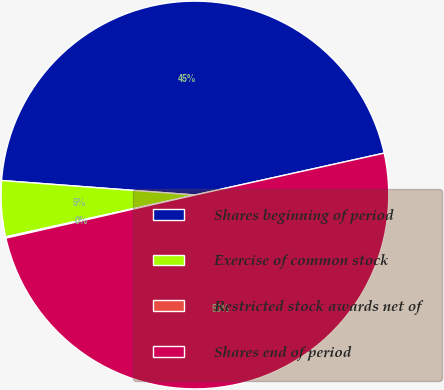Convert chart. <chart><loc_0><loc_0><loc_500><loc_500><pie_chart><fcel>Shares beginning of period<fcel>Exercise of common stock<fcel>Restricted stock awards net of<fcel>Shares end of period<nl><fcel>45.34%<fcel>4.66%<fcel>0.1%<fcel>49.9%<nl></chart> 